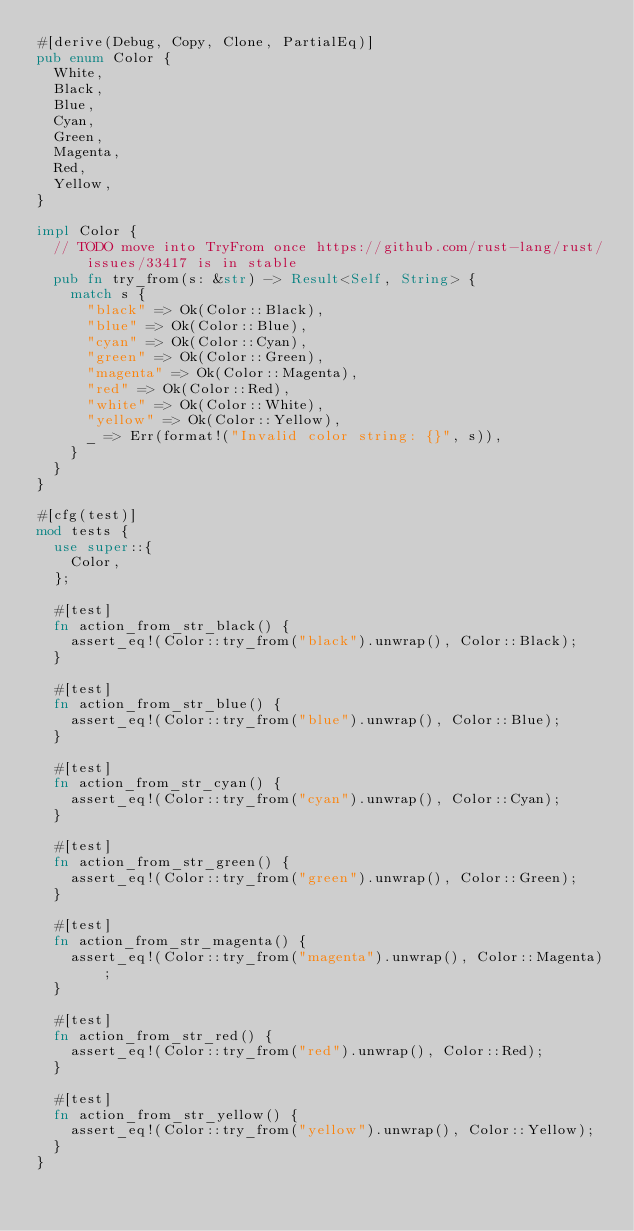<code> <loc_0><loc_0><loc_500><loc_500><_Rust_>#[derive(Debug, Copy, Clone, PartialEq)]
pub enum Color {
	White,
	Black,
	Blue,
	Cyan,
	Green,
	Magenta,
	Red,
	Yellow,
}

impl Color {
	// TODO move into TryFrom once https://github.com/rust-lang/rust/issues/33417 is in stable
	pub fn try_from(s: &str) -> Result<Self, String> {
		match s {
			"black" => Ok(Color::Black),
			"blue" => Ok(Color::Blue),
			"cyan" => Ok(Color::Cyan),
			"green" => Ok(Color::Green),
			"magenta" => Ok(Color::Magenta),
			"red" => Ok(Color::Red),
			"white" => Ok(Color::White),
			"yellow" => Ok(Color::Yellow),
			_ => Err(format!("Invalid color string: {}", s)),
		}
	}
}

#[cfg(test)]
mod tests {
	use super::{
		Color,
	};

	#[test]
	fn action_from_str_black() {
		assert_eq!(Color::try_from("black").unwrap(), Color::Black);
	}

	#[test]
	fn action_from_str_blue() {
		assert_eq!(Color::try_from("blue").unwrap(), Color::Blue);
	}

	#[test]
	fn action_from_str_cyan() {
		assert_eq!(Color::try_from("cyan").unwrap(), Color::Cyan);
	}

	#[test]
	fn action_from_str_green() {
		assert_eq!(Color::try_from("green").unwrap(), Color::Green);
	}

	#[test]
	fn action_from_str_magenta() {
		assert_eq!(Color::try_from("magenta").unwrap(), Color::Magenta);
	}

	#[test]
	fn action_from_str_red() {
		assert_eq!(Color::try_from("red").unwrap(), Color::Red);
	}

	#[test]
	fn action_from_str_yellow() {
		assert_eq!(Color::try_from("yellow").unwrap(), Color::Yellow);
	}
}
</code> 